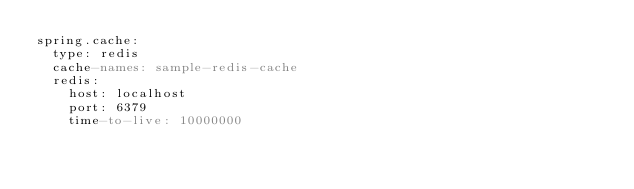Convert code to text. <code><loc_0><loc_0><loc_500><loc_500><_YAML_>spring.cache:
  type: redis
  cache-names: sample-redis-cache
  redis:
    host: localhost
    port: 6379
    time-to-live: 10000000
</code> 